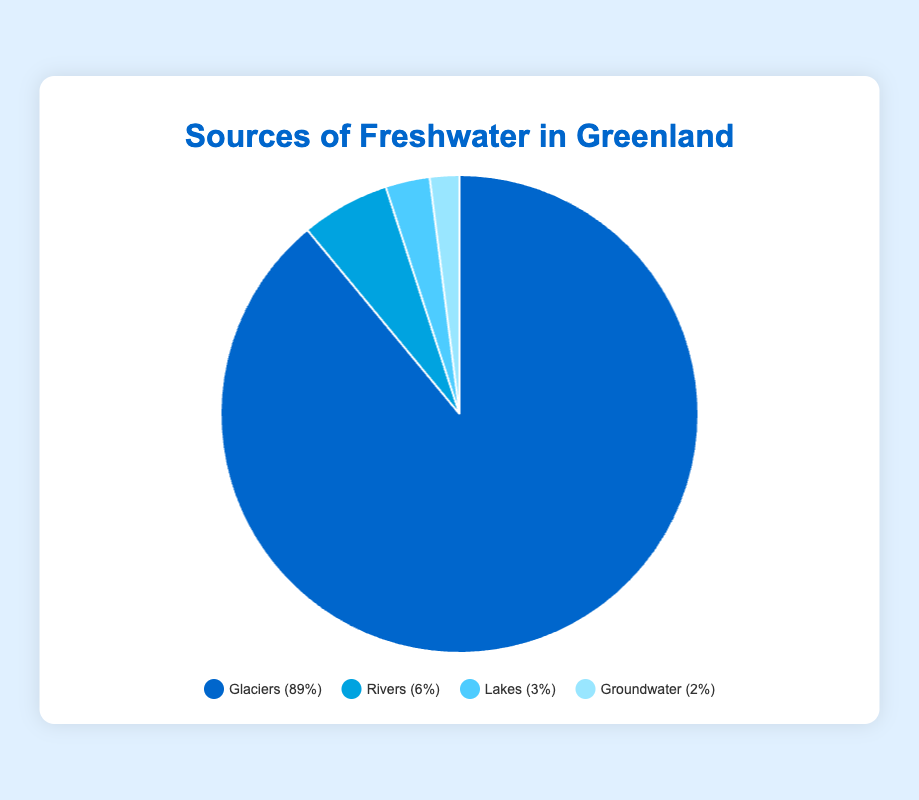How much more percentage do Glaciers contribute to freshwater sources compared to Rivers? To find the difference in contribution, subtract the percentage of Rivers (6%) from Glaciers (89%). 89 - 6 = 83
Answer: 83% Which source provides the least amount of freshwater in Greenland? By comparing the percentages of all sources, Groundwater has the smallest value at 2%.
Answer: Groundwater What is the combined percentage of Lakes and Groundwater as sources of freshwater in Greenland? Add the percentages of Lakes (3%) and Groundwater (2%). 3 + 2 = 5
Answer: 5% Is the contribution of Glaciers greater than all other sources combined? First, find the combined contribution of Rivers, Lakes, and Groundwater (6% + 3% + 2% = 11%). Then compare with that of Glaciers (89%). Since 89 > 11, Glaciers' contribution is indeed greater.
Answer: Yes Which source of freshwater has a dark blue color in the pie chart? The Glaciers section of the pie chart is colored dark blue, as described in the legend section.
Answer: Glaciers What is the visual representation (color) for the Rivers source in the pie chart? The Rivers source is represented by light blue color in the chart, as seen in the legend.
Answer: Light blue By how much does the percentage of Lakes exceed that of Groundwater? Subtract the percentage of Groundwater (2%) from Lakes (3%). 3 - 2 = 1
Answer: 1% What is the sum of percentages of all freshwater sources combined? Add the percentages of all sources: Glaciers (89%), Rivers (6%), Lakes (3%), and Groundwater (2%). 89 + 6 + 3 + 2 = 100
Answer: 100% Which two freshwater sources together contribute the same amount as Rivers? The sum of percentages for Lakes and Groundwater is 3% + 2% = 5%, which is not equal to Rivers (6%). So, no two sources combined equal the percentage of Rivers.
Answer: None What is the visual representation (color) for the Groundwater source in the pie chart? The Groundwater source is represented by the lightest blue color in the chart, as seen in the legend.
Answer: Lightest blue 